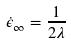<formula> <loc_0><loc_0><loc_500><loc_500>\dot { \epsilon } _ { \infty } = \frac { 1 } { 2 \lambda }</formula> 